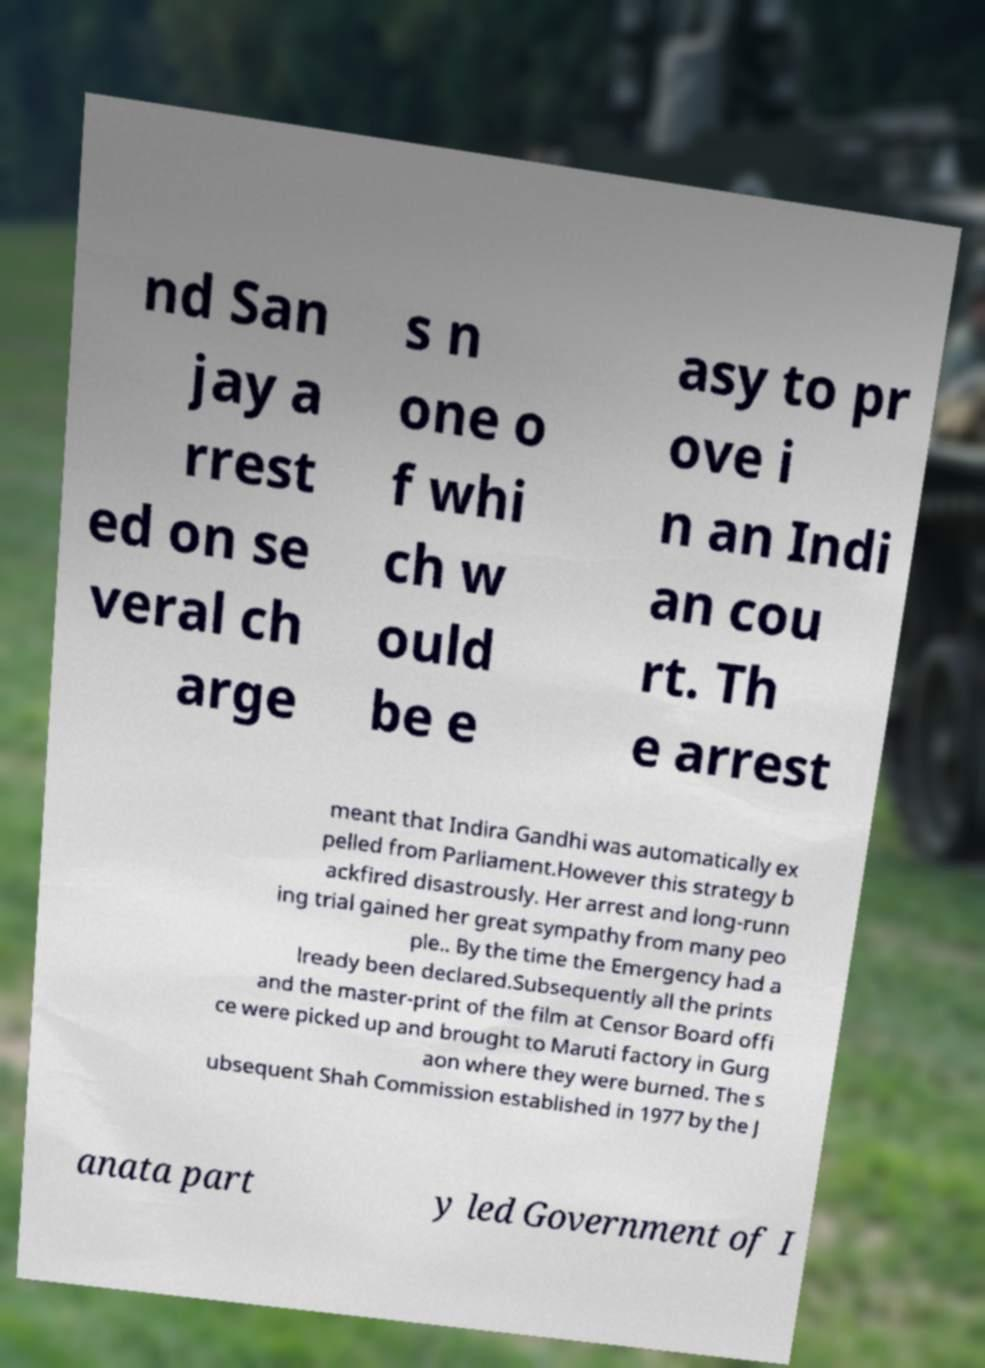Can you accurately transcribe the text from the provided image for me? nd San jay a rrest ed on se veral ch arge s n one o f whi ch w ould be e asy to pr ove i n an Indi an cou rt. Th e arrest meant that Indira Gandhi was automatically ex pelled from Parliament.However this strategy b ackfired disastrously. Her arrest and long-runn ing trial gained her great sympathy from many peo ple.. By the time the Emergency had a lready been declared.Subsequently all the prints and the master-print of the film at Censor Board offi ce were picked up and brought to Maruti factory in Gurg aon where they were burned. The s ubsequent Shah Commission established in 1977 by the J anata part y led Government of I 